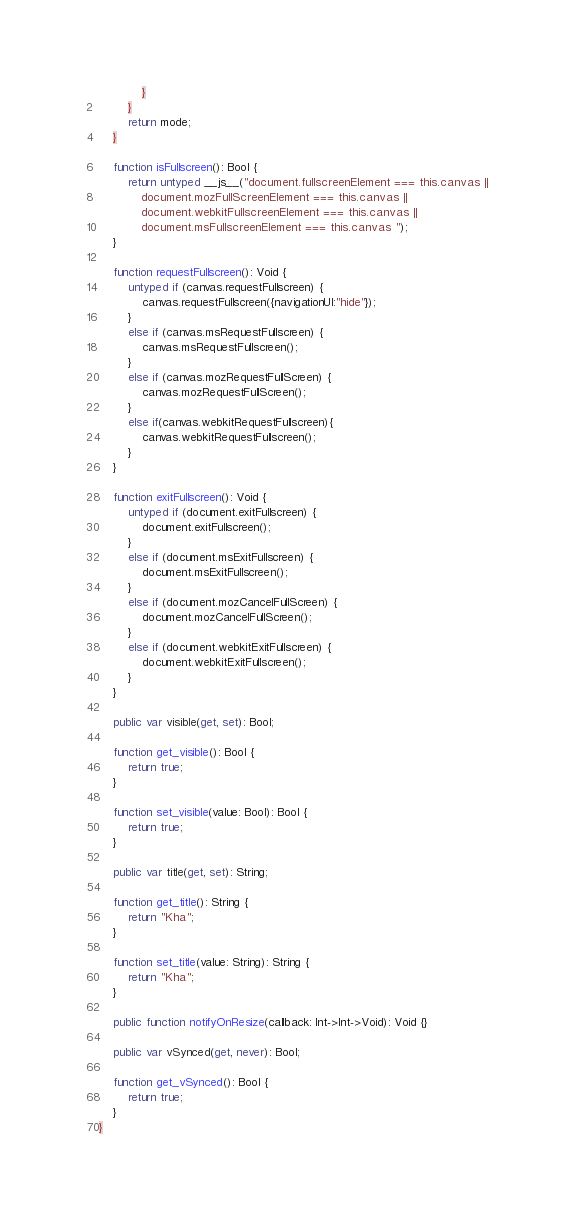<code> <loc_0><loc_0><loc_500><loc_500><_Haxe_>			}
		}
		return mode;
	}

	function isFullscreen(): Bool {
		return untyped __js__("document.fullscreenElement === this.canvas ||
			document.mozFullScreenElement === this.canvas ||
			document.webkitFullscreenElement === this.canvas ||
			document.msFullscreenElement === this.canvas ");
	}

	function requestFullscreen(): Void {
		untyped if (canvas.requestFullscreen) {
			canvas.requestFullscreen({navigationUI:"hide"});
		}
		else if (canvas.msRequestFullscreen) {
			canvas.msRequestFullscreen();
		}
		else if (canvas.mozRequestFullScreen) {
			canvas.mozRequestFullScreen();
		}
		else if(canvas.webkitRequestFullscreen){
			canvas.webkitRequestFullscreen();
		}
	}

	function exitFullscreen(): Void {
		untyped if (document.exitFullscreen) {
			document.exitFullscreen();
		}
		else if (document.msExitFullscreen) {
			document.msExitFullscreen();
		}
		else if (document.mozCancelFullScreen) {
			document.mozCancelFullScreen();
		}
		else if (document.webkitExitFullscreen) {
			document.webkitExitFullscreen();
		}
	}

	public var visible(get, set): Bool;

	function get_visible(): Bool {
		return true;
	}

	function set_visible(value: Bool): Bool {
		return true;
	}

	public var title(get, set): String;

	function get_title(): String {
		return "Kha";
	}

	function set_title(value: String): String {
		return "Kha";
	}

	public function notifyOnResize(callback: Int->Int->Void): Void {}

	public var vSynced(get, never): Bool;

	function get_vSynced(): Bool {
		return true;
	}
}
</code> 